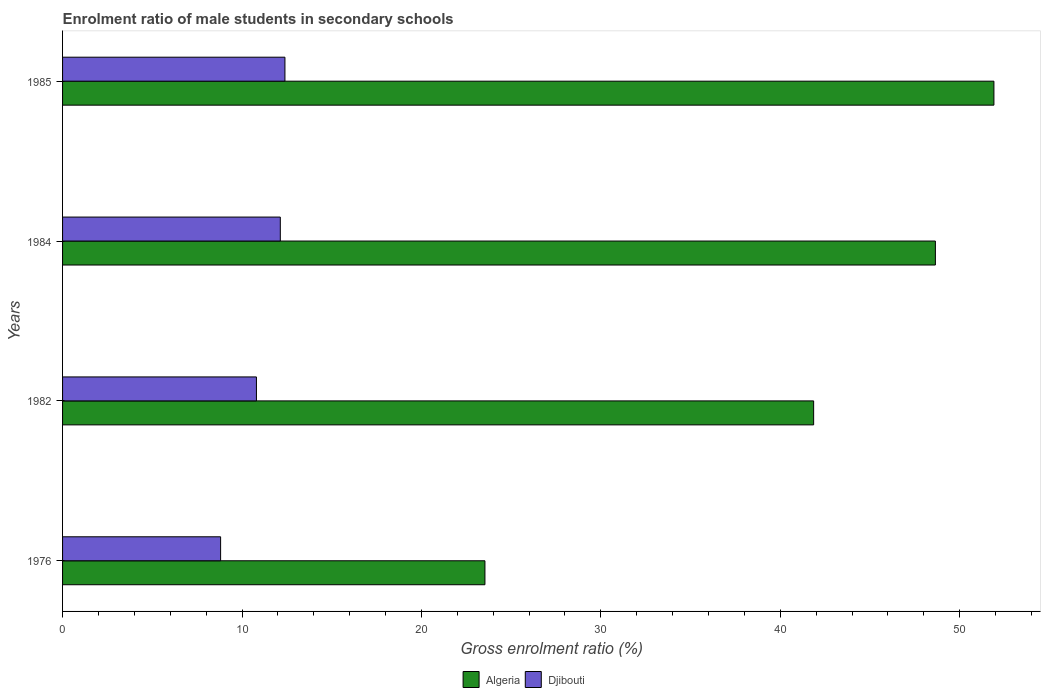How many different coloured bars are there?
Provide a short and direct response. 2. How many groups of bars are there?
Ensure brevity in your answer.  4. How many bars are there on the 4th tick from the top?
Your response must be concise. 2. What is the label of the 1st group of bars from the top?
Offer a terse response. 1985. What is the enrolment ratio of male students in secondary schools in Algeria in 1984?
Keep it short and to the point. 48.64. Across all years, what is the maximum enrolment ratio of male students in secondary schools in Algeria?
Ensure brevity in your answer.  51.91. Across all years, what is the minimum enrolment ratio of male students in secondary schools in Djibouti?
Keep it short and to the point. 8.81. In which year was the enrolment ratio of male students in secondary schools in Algeria maximum?
Offer a terse response. 1985. In which year was the enrolment ratio of male students in secondary schools in Algeria minimum?
Offer a terse response. 1976. What is the total enrolment ratio of male students in secondary schools in Algeria in the graph?
Offer a very short reply. 165.95. What is the difference between the enrolment ratio of male students in secondary schools in Algeria in 1976 and that in 1984?
Ensure brevity in your answer.  -25.1. What is the difference between the enrolment ratio of male students in secondary schools in Djibouti in 1985 and the enrolment ratio of male students in secondary schools in Algeria in 1976?
Your answer should be very brief. -11.15. What is the average enrolment ratio of male students in secondary schools in Algeria per year?
Offer a very short reply. 41.49. In the year 1985, what is the difference between the enrolment ratio of male students in secondary schools in Algeria and enrolment ratio of male students in secondary schools in Djibouti?
Provide a short and direct response. 39.51. What is the ratio of the enrolment ratio of male students in secondary schools in Djibouti in 1976 to that in 1984?
Your answer should be compact. 0.73. Is the enrolment ratio of male students in secondary schools in Djibouti in 1984 less than that in 1985?
Keep it short and to the point. Yes. Is the difference between the enrolment ratio of male students in secondary schools in Algeria in 1976 and 1982 greater than the difference between the enrolment ratio of male students in secondary schools in Djibouti in 1976 and 1982?
Give a very brief answer. No. What is the difference between the highest and the second highest enrolment ratio of male students in secondary schools in Djibouti?
Your answer should be very brief. 0.26. What is the difference between the highest and the lowest enrolment ratio of male students in secondary schools in Algeria?
Give a very brief answer. 28.37. Is the sum of the enrolment ratio of male students in secondary schools in Algeria in 1976 and 1985 greater than the maximum enrolment ratio of male students in secondary schools in Djibouti across all years?
Ensure brevity in your answer.  Yes. What does the 1st bar from the top in 1984 represents?
Your response must be concise. Djibouti. What does the 2nd bar from the bottom in 1985 represents?
Give a very brief answer. Djibouti. How many years are there in the graph?
Keep it short and to the point. 4. What is the difference between two consecutive major ticks on the X-axis?
Offer a very short reply. 10. Are the values on the major ticks of X-axis written in scientific E-notation?
Offer a terse response. No. Does the graph contain grids?
Provide a succinct answer. No. Where does the legend appear in the graph?
Give a very brief answer. Bottom center. How are the legend labels stacked?
Offer a very short reply. Horizontal. What is the title of the graph?
Your answer should be compact. Enrolment ratio of male students in secondary schools. Does "Estonia" appear as one of the legend labels in the graph?
Provide a succinct answer. No. What is the Gross enrolment ratio (%) in Algeria in 1976?
Ensure brevity in your answer.  23.54. What is the Gross enrolment ratio (%) in Djibouti in 1976?
Provide a succinct answer. 8.81. What is the Gross enrolment ratio (%) of Algeria in 1982?
Provide a succinct answer. 41.86. What is the Gross enrolment ratio (%) of Djibouti in 1982?
Your answer should be very brief. 10.8. What is the Gross enrolment ratio (%) of Algeria in 1984?
Keep it short and to the point. 48.64. What is the Gross enrolment ratio (%) of Djibouti in 1984?
Make the answer very short. 12.14. What is the Gross enrolment ratio (%) of Algeria in 1985?
Your answer should be compact. 51.91. What is the Gross enrolment ratio (%) of Djibouti in 1985?
Give a very brief answer. 12.39. Across all years, what is the maximum Gross enrolment ratio (%) in Algeria?
Give a very brief answer. 51.91. Across all years, what is the maximum Gross enrolment ratio (%) in Djibouti?
Offer a terse response. 12.39. Across all years, what is the minimum Gross enrolment ratio (%) of Algeria?
Offer a terse response. 23.54. Across all years, what is the minimum Gross enrolment ratio (%) of Djibouti?
Provide a succinct answer. 8.81. What is the total Gross enrolment ratio (%) of Algeria in the graph?
Provide a short and direct response. 165.95. What is the total Gross enrolment ratio (%) of Djibouti in the graph?
Offer a terse response. 44.14. What is the difference between the Gross enrolment ratio (%) in Algeria in 1976 and that in 1982?
Your answer should be very brief. -18.32. What is the difference between the Gross enrolment ratio (%) in Djibouti in 1976 and that in 1982?
Your response must be concise. -2. What is the difference between the Gross enrolment ratio (%) of Algeria in 1976 and that in 1984?
Ensure brevity in your answer.  -25.1. What is the difference between the Gross enrolment ratio (%) in Djibouti in 1976 and that in 1984?
Ensure brevity in your answer.  -3.33. What is the difference between the Gross enrolment ratio (%) in Algeria in 1976 and that in 1985?
Ensure brevity in your answer.  -28.37. What is the difference between the Gross enrolment ratio (%) of Djibouti in 1976 and that in 1985?
Make the answer very short. -3.58. What is the difference between the Gross enrolment ratio (%) of Algeria in 1982 and that in 1984?
Provide a short and direct response. -6.79. What is the difference between the Gross enrolment ratio (%) of Djibouti in 1982 and that in 1984?
Your answer should be compact. -1.33. What is the difference between the Gross enrolment ratio (%) of Algeria in 1982 and that in 1985?
Your response must be concise. -10.05. What is the difference between the Gross enrolment ratio (%) of Djibouti in 1982 and that in 1985?
Provide a short and direct response. -1.59. What is the difference between the Gross enrolment ratio (%) of Algeria in 1984 and that in 1985?
Your answer should be compact. -3.26. What is the difference between the Gross enrolment ratio (%) in Djibouti in 1984 and that in 1985?
Make the answer very short. -0.26. What is the difference between the Gross enrolment ratio (%) of Algeria in 1976 and the Gross enrolment ratio (%) of Djibouti in 1982?
Give a very brief answer. 12.74. What is the difference between the Gross enrolment ratio (%) of Algeria in 1976 and the Gross enrolment ratio (%) of Djibouti in 1984?
Offer a terse response. 11.4. What is the difference between the Gross enrolment ratio (%) of Algeria in 1976 and the Gross enrolment ratio (%) of Djibouti in 1985?
Provide a short and direct response. 11.15. What is the difference between the Gross enrolment ratio (%) in Algeria in 1982 and the Gross enrolment ratio (%) in Djibouti in 1984?
Offer a very short reply. 29.72. What is the difference between the Gross enrolment ratio (%) of Algeria in 1982 and the Gross enrolment ratio (%) of Djibouti in 1985?
Offer a very short reply. 29.47. What is the difference between the Gross enrolment ratio (%) in Algeria in 1984 and the Gross enrolment ratio (%) in Djibouti in 1985?
Keep it short and to the point. 36.25. What is the average Gross enrolment ratio (%) in Algeria per year?
Offer a very short reply. 41.49. What is the average Gross enrolment ratio (%) in Djibouti per year?
Your response must be concise. 11.04. In the year 1976, what is the difference between the Gross enrolment ratio (%) in Algeria and Gross enrolment ratio (%) in Djibouti?
Make the answer very short. 14.73. In the year 1982, what is the difference between the Gross enrolment ratio (%) of Algeria and Gross enrolment ratio (%) of Djibouti?
Provide a short and direct response. 31.05. In the year 1984, what is the difference between the Gross enrolment ratio (%) of Algeria and Gross enrolment ratio (%) of Djibouti?
Offer a very short reply. 36.51. In the year 1985, what is the difference between the Gross enrolment ratio (%) in Algeria and Gross enrolment ratio (%) in Djibouti?
Provide a succinct answer. 39.51. What is the ratio of the Gross enrolment ratio (%) of Algeria in 1976 to that in 1982?
Make the answer very short. 0.56. What is the ratio of the Gross enrolment ratio (%) of Djibouti in 1976 to that in 1982?
Provide a succinct answer. 0.82. What is the ratio of the Gross enrolment ratio (%) of Algeria in 1976 to that in 1984?
Make the answer very short. 0.48. What is the ratio of the Gross enrolment ratio (%) of Djibouti in 1976 to that in 1984?
Your answer should be very brief. 0.73. What is the ratio of the Gross enrolment ratio (%) of Algeria in 1976 to that in 1985?
Your answer should be very brief. 0.45. What is the ratio of the Gross enrolment ratio (%) of Djibouti in 1976 to that in 1985?
Provide a succinct answer. 0.71. What is the ratio of the Gross enrolment ratio (%) in Algeria in 1982 to that in 1984?
Offer a very short reply. 0.86. What is the ratio of the Gross enrolment ratio (%) in Djibouti in 1982 to that in 1984?
Provide a succinct answer. 0.89. What is the ratio of the Gross enrolment ratio (%) of Algeria in 1982 to that in 1985?
Make the answer very short. 0.81. What is the ratio of the Gross enrolment ratio (%) of Djibouti in 1982 to that in 1985?
Ensure brevity in your answer.  0.87. What is the ratio of the Gross enrolment ratio (%) of Algeria in 1984 to that in 1985?
Give a very brief answer. 0.94. What is the ratio of the Gross enrolment ratio (%) of Djibouti in 1984 to that in 1985?
Offer a very short reply. 0.98. What is the difference between the highest and the second highest Gross enrolment ratio (%) in Algeria?
Ensure brevity in your answer.  3.26. What is the difference between the highest and the second highest Gross enrolment ratio (%) of Djibouti?
Provide a short and direct response. 0.26. What is the difference between the highest and the lowest Gross enrolment ratio (%) in Algeria?
Ensure brevity in your answer.  28.37. What is the difference between the highest and the lowest Gross enrolment ratio (%) in Djibouti?
Give a very brief answer. 3.58. 